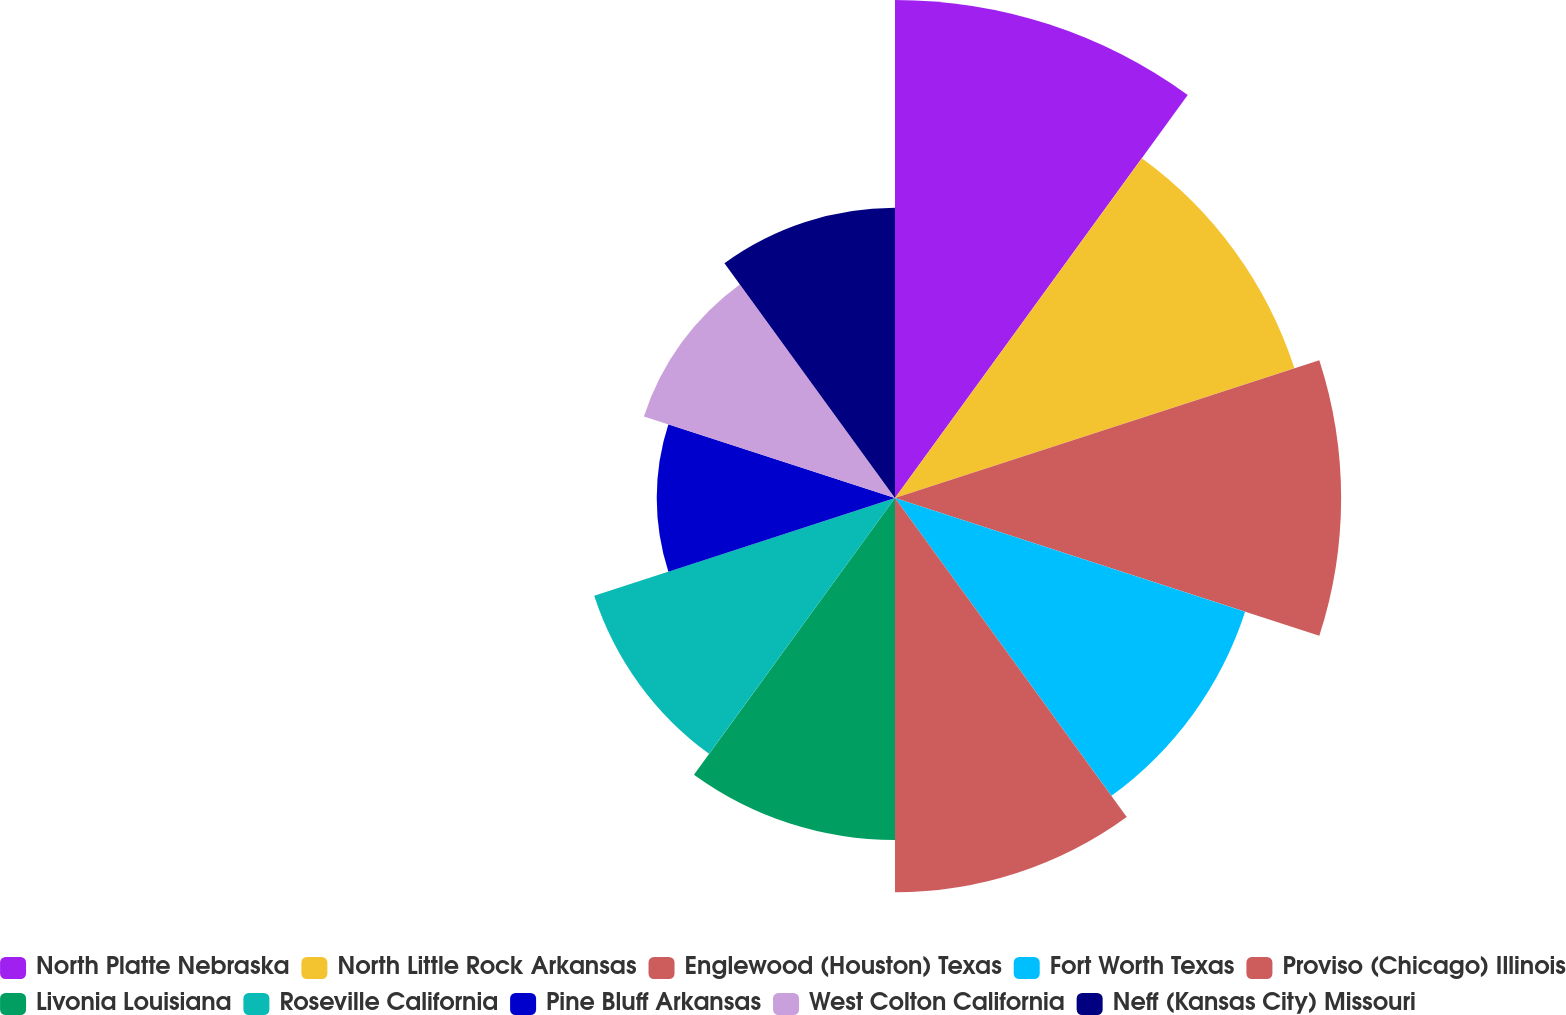Convert chart to OTSL. <chart><loc_0><loc_0><loc_500><loc_500><pie_chart><fcel>North Platte Nebraska<fcel>North Little Rock Arkansas<fcel>Englewood (Houston) Texas<fcel>Fort Worth Texas<fcel>Proviso (Chicago) Illinois<fcel>Livonia Louisiana<fcel>Roseville California<fcel>Pine Bluff Arkansas<fcel>West Colton California<fcel>Neff (Kansas City) Missouri<nl><fcel>13.92%<fcel>11.74%<fcel>12.47%<fcel>10.29%<fcel>11.02%<fcel>9.56%<fcel>8.84%<fcel>6.66%<fcel>7.38%<fcel>8.11%<nl></chart> 